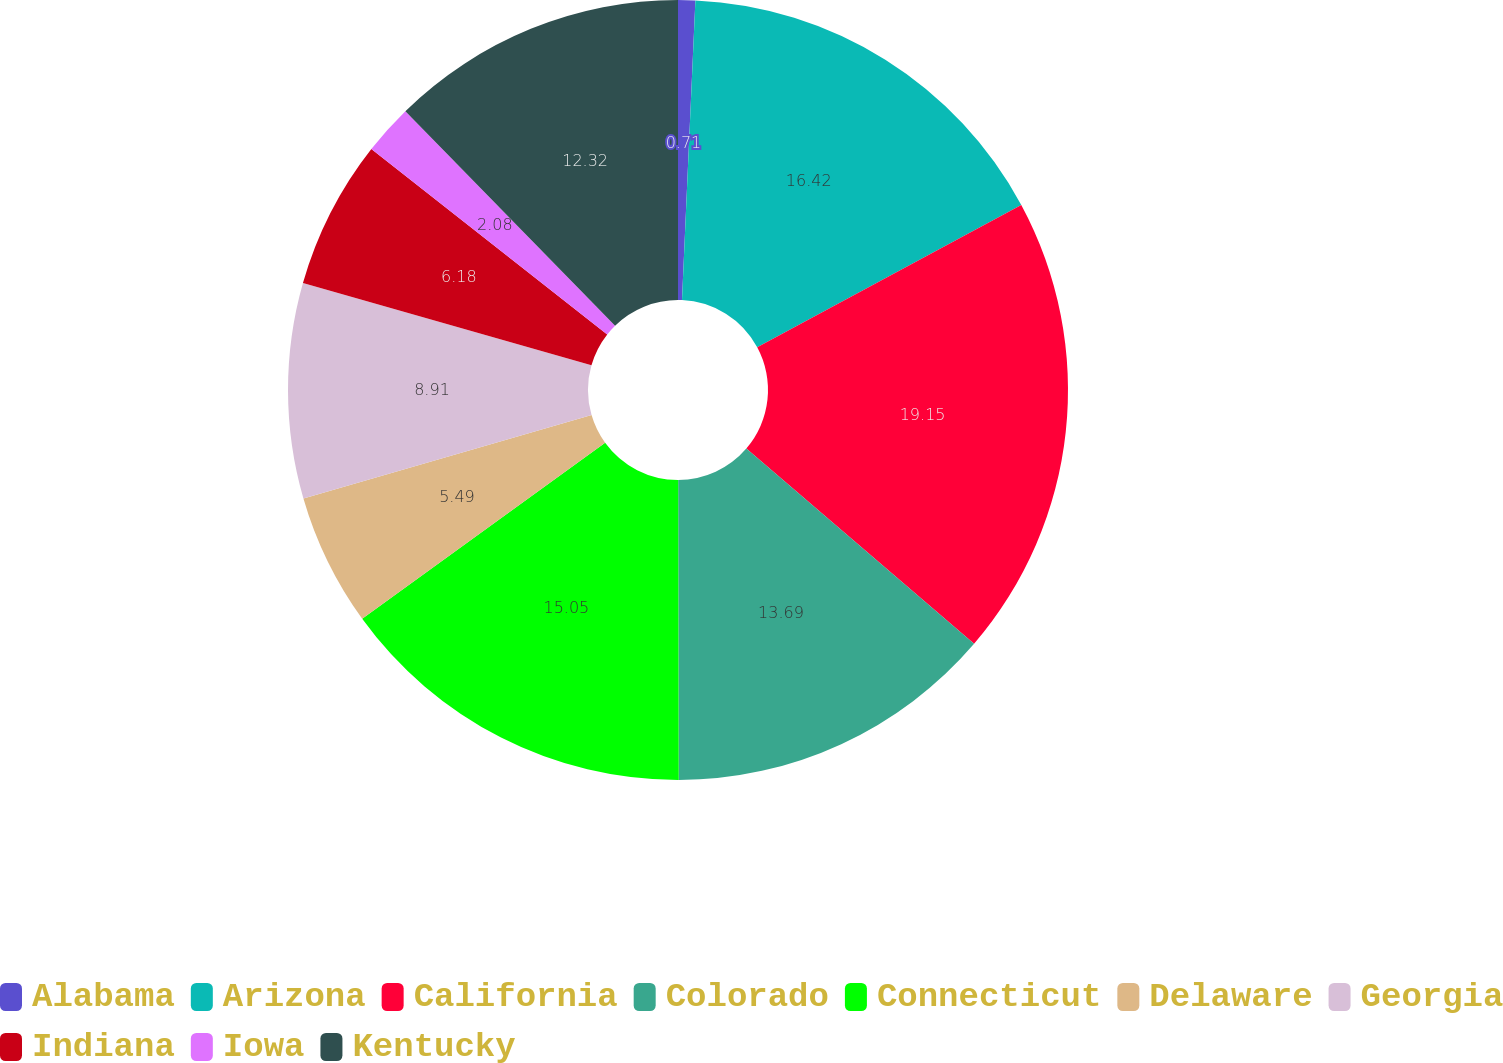Convert chart to OTSL. <chart><loc_0><loc_0><loc_500><loc_500><pie_chart><fcel>Alabama<fcel>Arizona<fcel>California<fcel>Colorado<fcel>Connecticut<fcel>Delaware<fcel>Georgia<fcel>Indiana<fcel>Iowa<fcel>Kentucky<nl><fcel>0.71%<fcel>16.42%<fcel>19.15%<fcel>13.69%<fcel>15.05%<fcel>5.49%<fcel>8.91%<fcel>6.18%<fcel>2.08%<fcel>12.32%<nl></chart> 